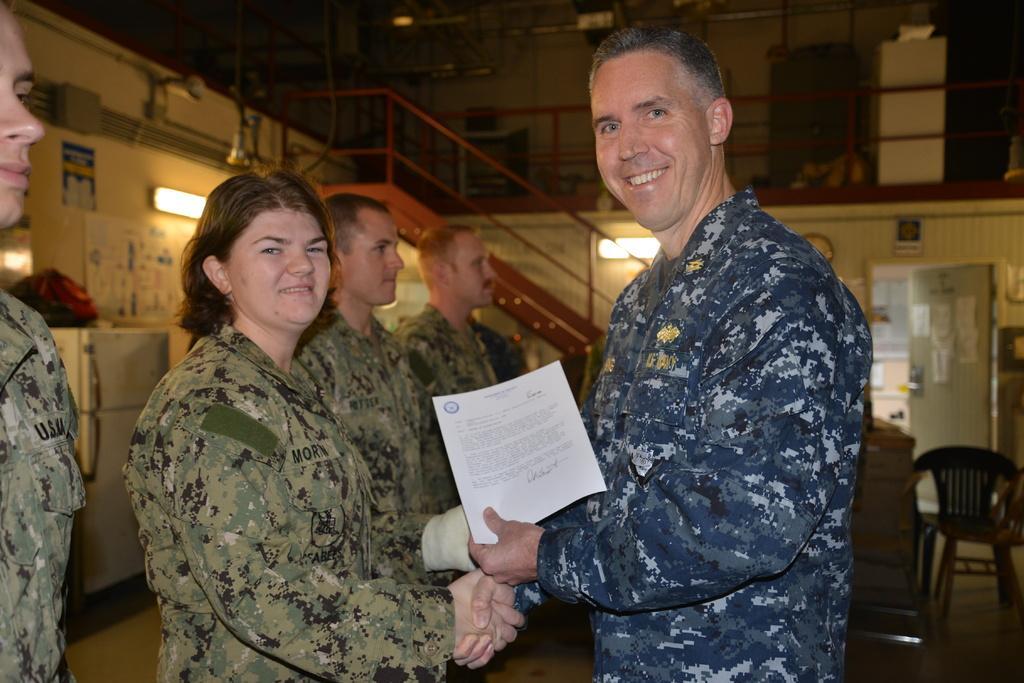How would you summarize this image in a sentence or two? In this image I can see few people are standing. Here I can see a man is smiling and holding a paper. In the background I can see a chair and a refrigerator. 